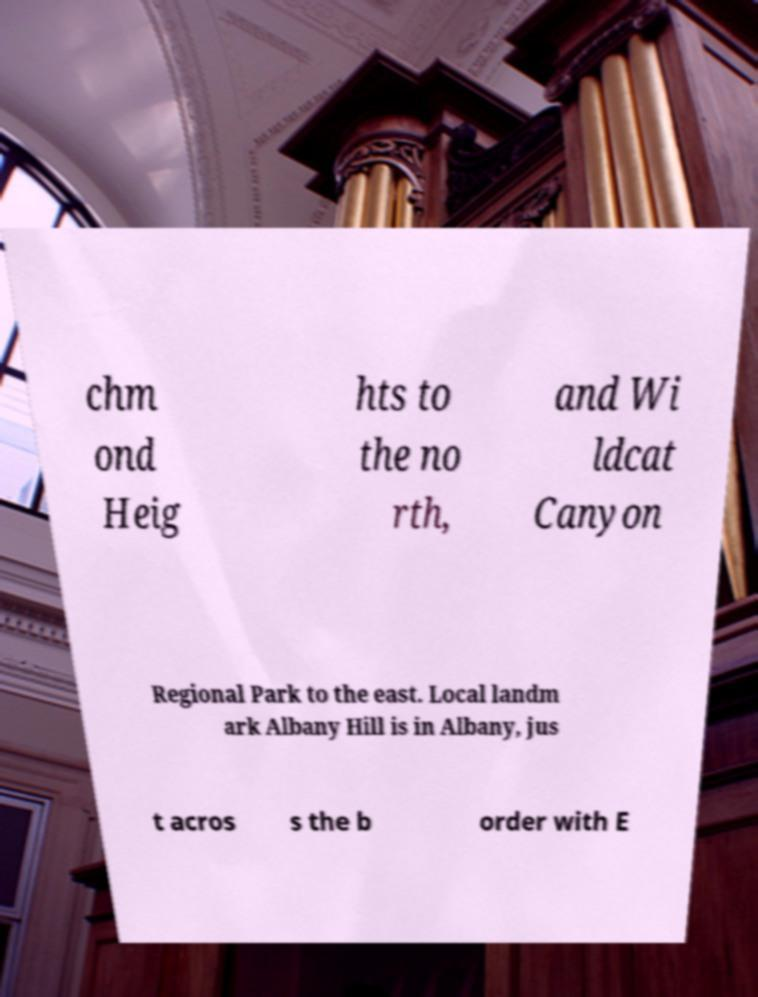What messages or text are displayed in this image? I need them in a readable, typed format. chm ond Heig hts to the no rth, and Wi ldcat Canyon Regional Park to the east. Local landm ark Albany Hill is in Albany, jus t acros s the b order with E 